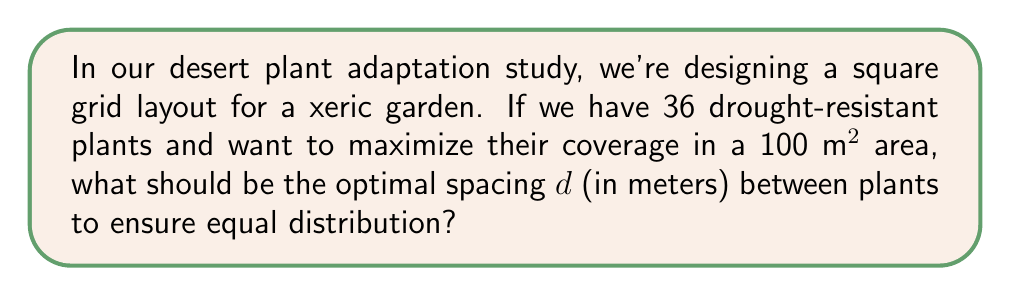Help me with this question. Let's approach this step-by-step:

1) We have a square grid, so the plants will form a 6x6 arrangement (since $6^2 = 36$).

2) The area of the square grid is 100 m². The side length of this square is:
   $s = \sqrt{100} = 10$ m

3) In a 6x6 grid, there are 5 spaces between plants in each row and column.

4) Let $d$ be the distance between plants. Then:
   $5d + d = 10$ (the total length of 5 spaces plus one plant diameter)

5) Solving for $d$:
   $6d = 10$
   $d = \frac{10}{6} = \frac{5}{3}$ m

6) To verify:
   - Number of plants per side: 6
   - Number of spaces per side: 5
   - Total length: $5 \cdot \frac{5}{3} + \frac{5}{3} = \frac{25}{3} + \frac{5}{3} = \frac{30}{3} = 10$ m

Therefore, the optimal spacing between plants is $\frac{5}{3}$ m or approximately 1.67 m.
Answer: $\frac{5}{3}$ m 